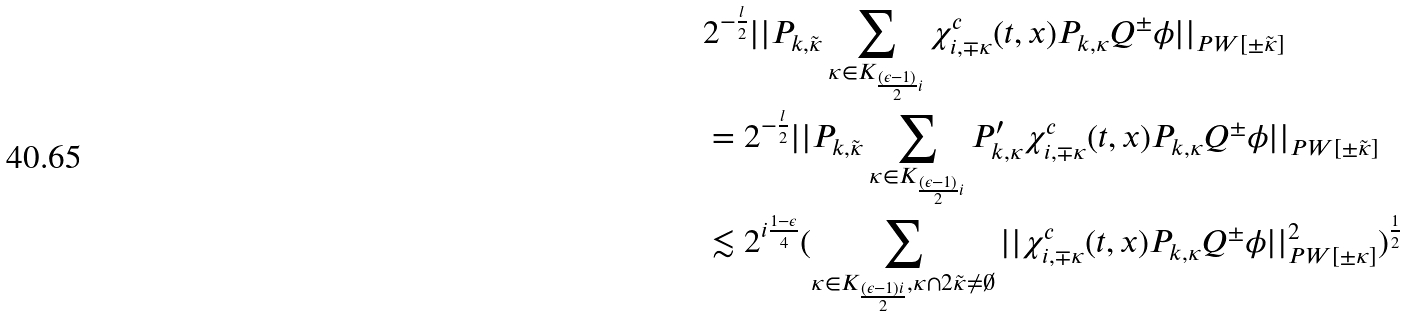<formula> <loc_0><loc_0><loc_500><loc_500>& 2 ^ { - \frac { l } { 2 } } | | P _ { k , \tilde { \kappa } } \sum _ { \kappa \in K _ { \frac { ( \epsilon - 1 ) } { 2 } i } } \chi ^ { c } _ { i , \mp \kappa } ( t , x ) P _ { k , \kappa } Q ^ { \pm } \phi | | _ { P W [ \pm \tilde { \kappa } ] } \\ & = 2 ^ { - \frac { l } { 2 } } | | P _ { k , \tilde { \kappa } } \sum _ { \kappa \in K _ { \frac { ( \epsilon - 1 ) } { 2 } i } } P ^ { \prime } _ { k , \kappa } \chi ^ { c } _ { i , \mp \kappa } ( t , x ) P _ { k , \kappa } Q ^ { \pm } \phi | | _ { P W [ \pm \tilde { \kappa } ] } \\ & \lesssim 2 ^ { i \frac { 1 - \epsilon } { 4 } } ( \sum _ { \kappa \in K _ { \frac { ( \epsilon - 1 ) i } { 2 } } , \kappa \cap 2 \tilde { \kappa } \neq \emptyset } | | \chi ^ { c } _ { i , \mp \kappa } ( t , x ) P _ { k , \kappa } Q ^ { \pm } \phi | | _ { P W [ \pm \kappa ] } ^ { 2 } ) ^ { \frac { 1 } { 2 } } \\</formula> 